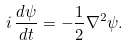Convert formula to latex. <formula><loc_0><loc_0><loc_500><loc_500>i \, \frac { d \psi } { d t } = - \frac { 1 } { 2 } \nabla ^ { 2 } \psi .</formula> 